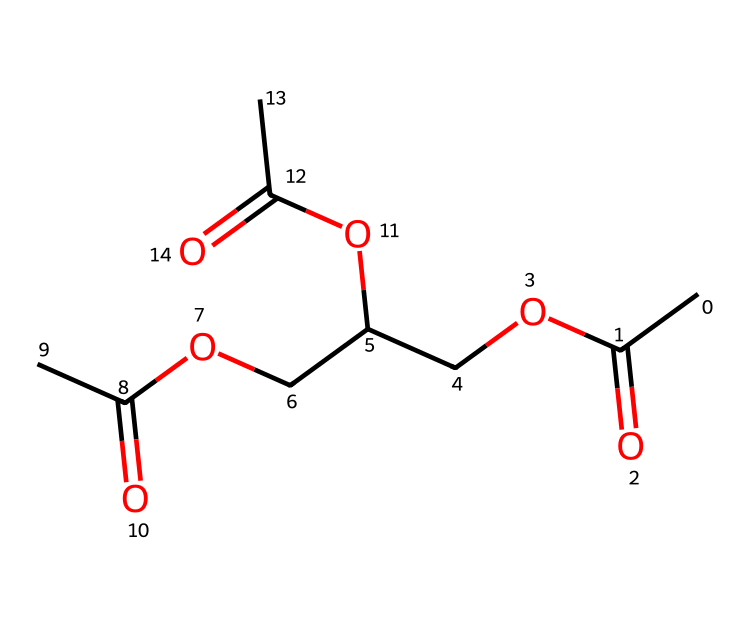what is the name of this chemical? The chemical structure corresponds to triacetin, which is an ester formed from glycerol and acetic acid. The presence of three acetyl groups (indicated by the three carbonyl =O and the ethyl groups) confirms this name.
Answer: triacetin how many carbon atoms are in the chemical? By analyzing the SMILES representation, we count the carbon atoms: there are 9 carbon atoms total; 6 from the three acetate groups (C(=O)O) and 3 from the connecting ether chains.
Answer: 9 how many ester functional groups are present in the structure? The structure contains three ester functional groups, each represented as COO in the SMILES. Each acetyl group connects with glycerol to form a distinct ester linkage.
Answer: 3 what type of functional groups are present in the chemical? The chemical contains ester functional groups, indicated by the COO linkages, and it also has carbonyl groups (C=O) from each acetate group. There are no other significant functional groups in the structure.
Answer: ester what is the molecular formula of the chemical? Analyzing the components from the SMILES shows the molecular formula is C9H16O6. We derive this by counting the total atoms of each element: 9 carbons (C), 16 hydrogens (H), and 6 oxygens (O).
Answer: C9H16O6 how many oxygen atoms are there in the chemical? By examining the SMILES representation, we note that there are 6 oxygen atoms in total: 3 from the ester groups and 3 from the carbonyl groups. Counting confirms this total.
Answer: 6 